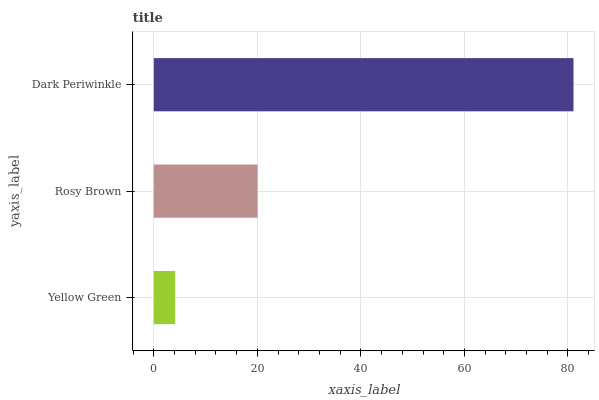Is Yellow Green the minimum?
Answer yes or no. Yes. Is Dark Periwinkle the maximum?
Answer yes or no. Yes. Is Rosy Brown the minimum?
Answer yes or no. No. Is Rosy Brown the maximum?
Answer yes or no. No. Is Rosy Brown greater than Yellow Green?
Answer yes or no. Yes. Is Yellow Green less than Rosy Brown?
Answer yes or no. Yes. Is Yellow Green greater than Rosy Brown?
Answer yes or no. No. Is Rosy Brown less than Yellow Green?
Answer yes or no. No. Is Rosy Brown the high median?
Answer yes or no. Yes. Is Rosy Brown the low median?
Answer yes or no. Yes. Is Dark Periwinkle the high median?
Answer yes or no. No. Is Yellow Green the low median?
Answer yes or no. No. 